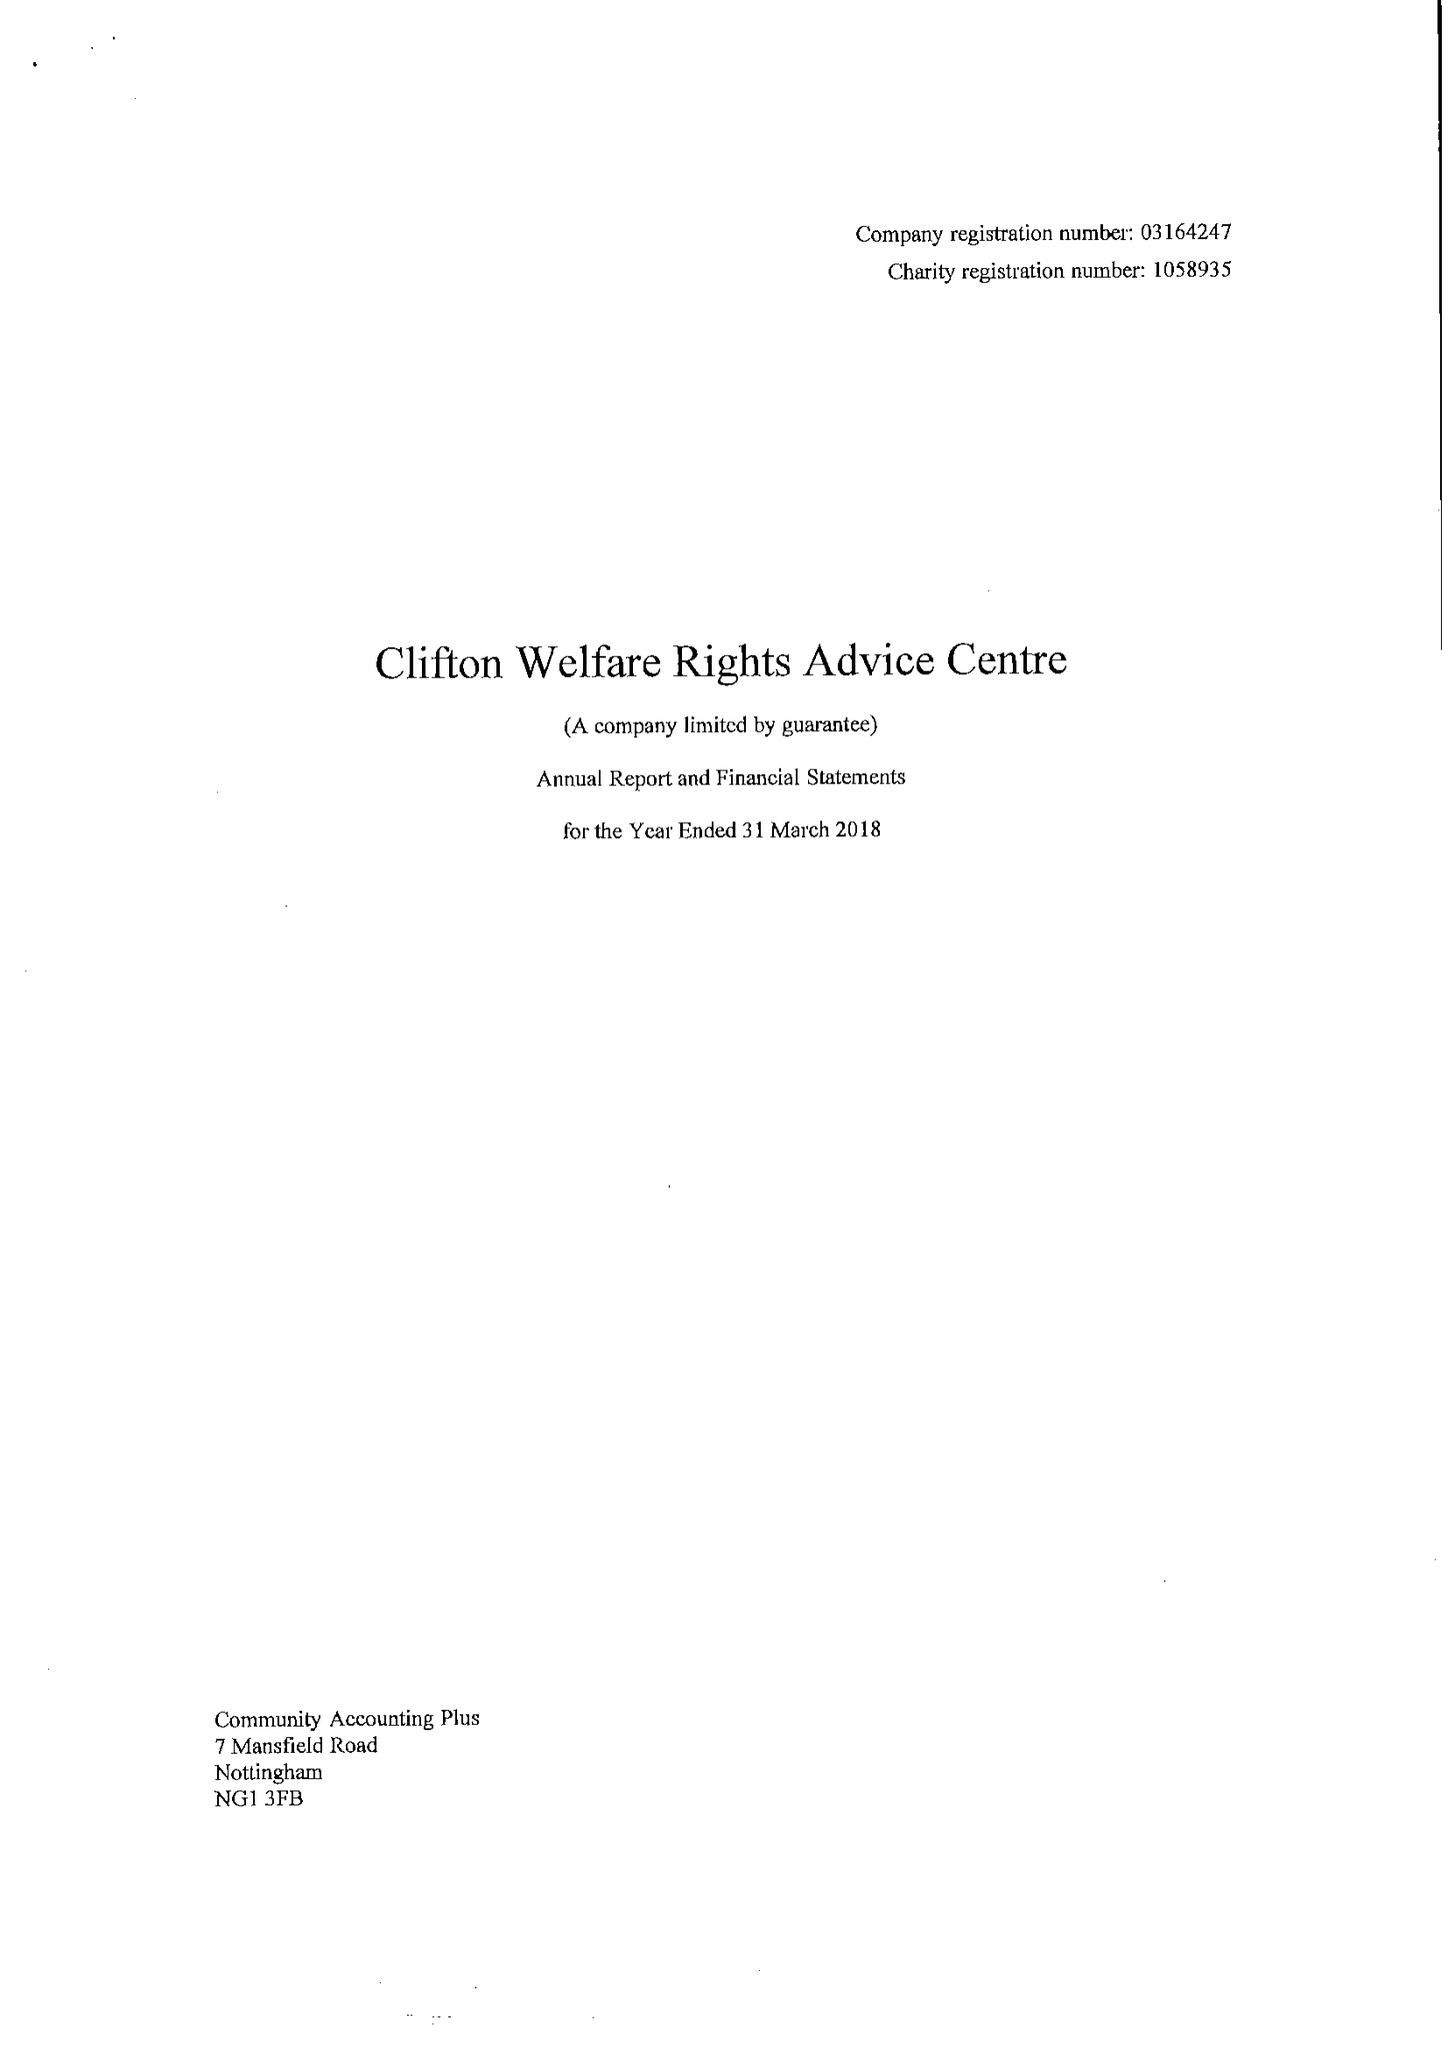What is the value for the charity_number?
Answer the question using a single word or phrase. 1058935 